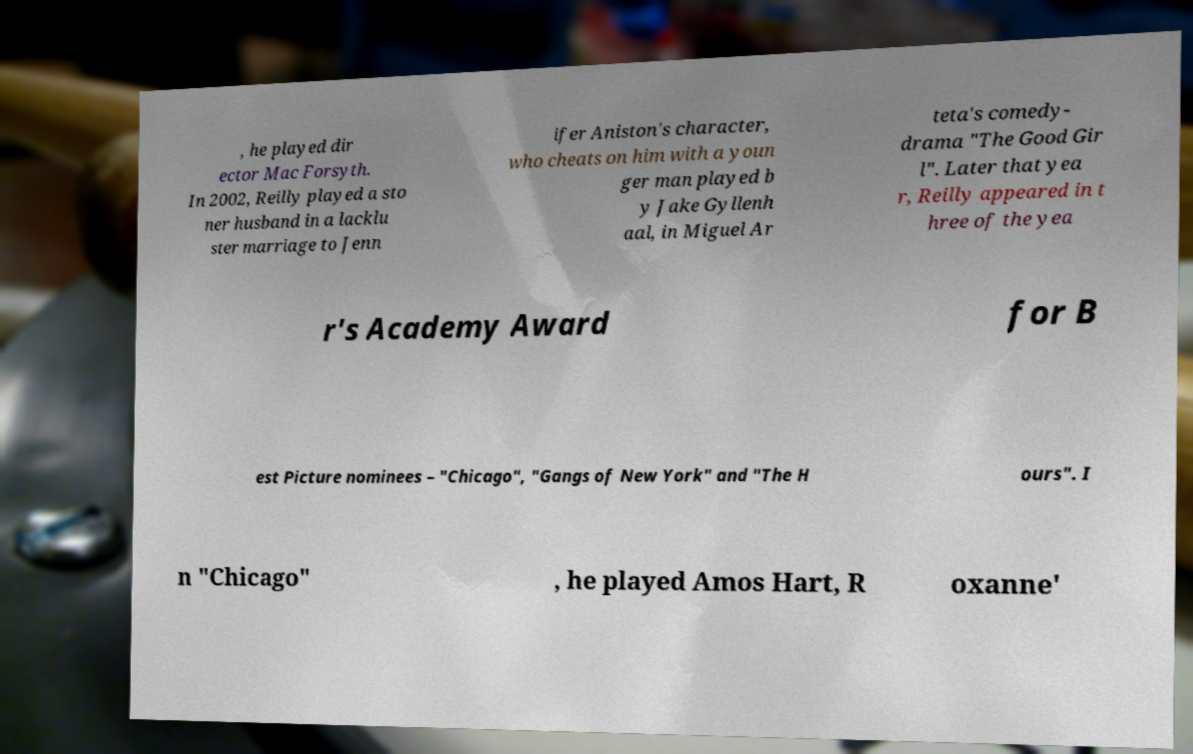For documentation purposes, I need the text within this image transcribed. Could you provide that? , he played dir ector Mac Forsyth. In 2002, Reilly played a sto ner husband in a lacklu ster marriage to Jenn ifer Aniston's character, who cheats on him with a youn ger man played b y Jake Gyllenh aal, in Miguel Ar teta's comedy- drama "The Good Gir l". Later that yea r, Reilly appeared in t hree of the yea r's Academy Award for B est Picture nominees – "Chicago", "Gangs of New York" and "The H ours". I n "Chicago" , he played Amos Hart, R oxanne' 